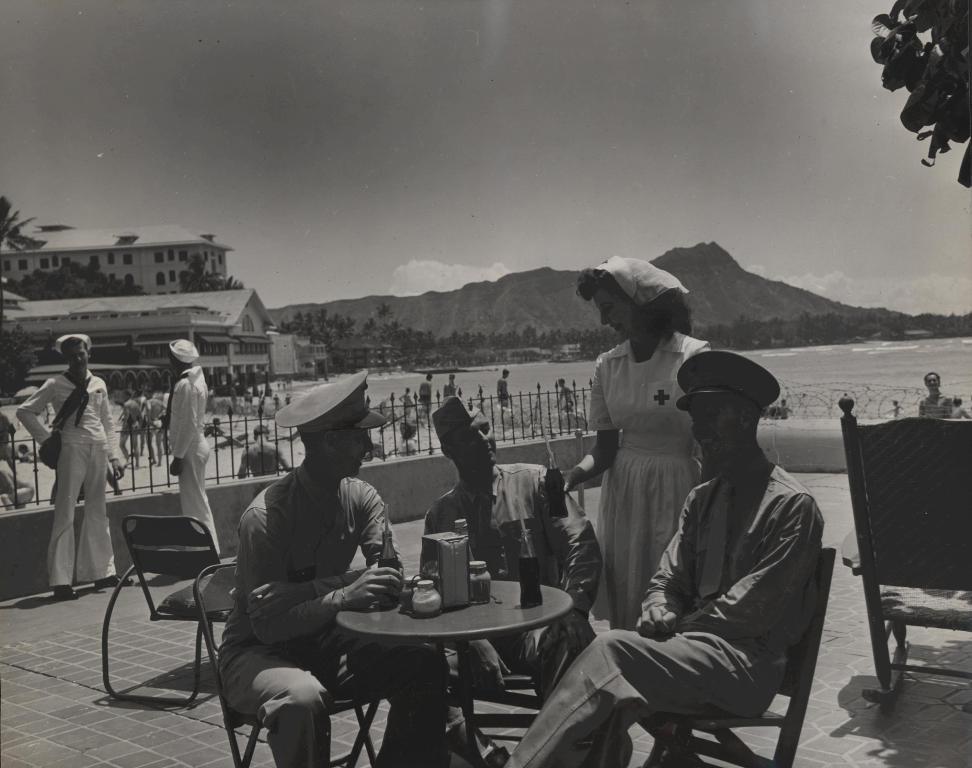How would you summarize this image in a sentence or two? There are three people sitting in chair and there is a table in front of them and the person wearing white dress is standing and there is a building in the left corner and there is a mountain and river in the background. 